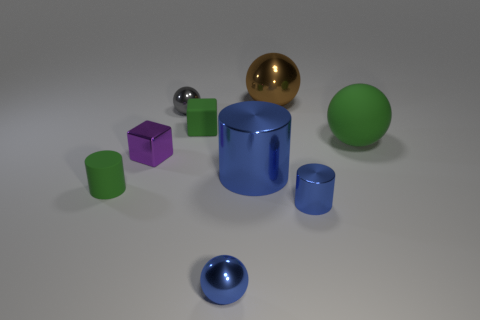Subtract all small cylinders. How many cylinders are left? 1 Subtract all cubes. How many objects are left? 7 Subtract all yellow balls. How many blue cylinders are left? 2 Add 1 brown spheres. How many objects exist? 10 Subtract all blue spheres. How many spheres are left? 3 Subtract 3 cylinders. How many cylinders are left? 0 Subtract 0 gray blocks. How many objects are left? 9 Subtract all cyan cylinders. Subtract all cyan blocks. How many cylinders are left? 3 Subtract all yellow shiny cylinders. Subtract all big things. How many objects are left? 6 Add 4 small blue objects. How many small blue objects are left? 6 